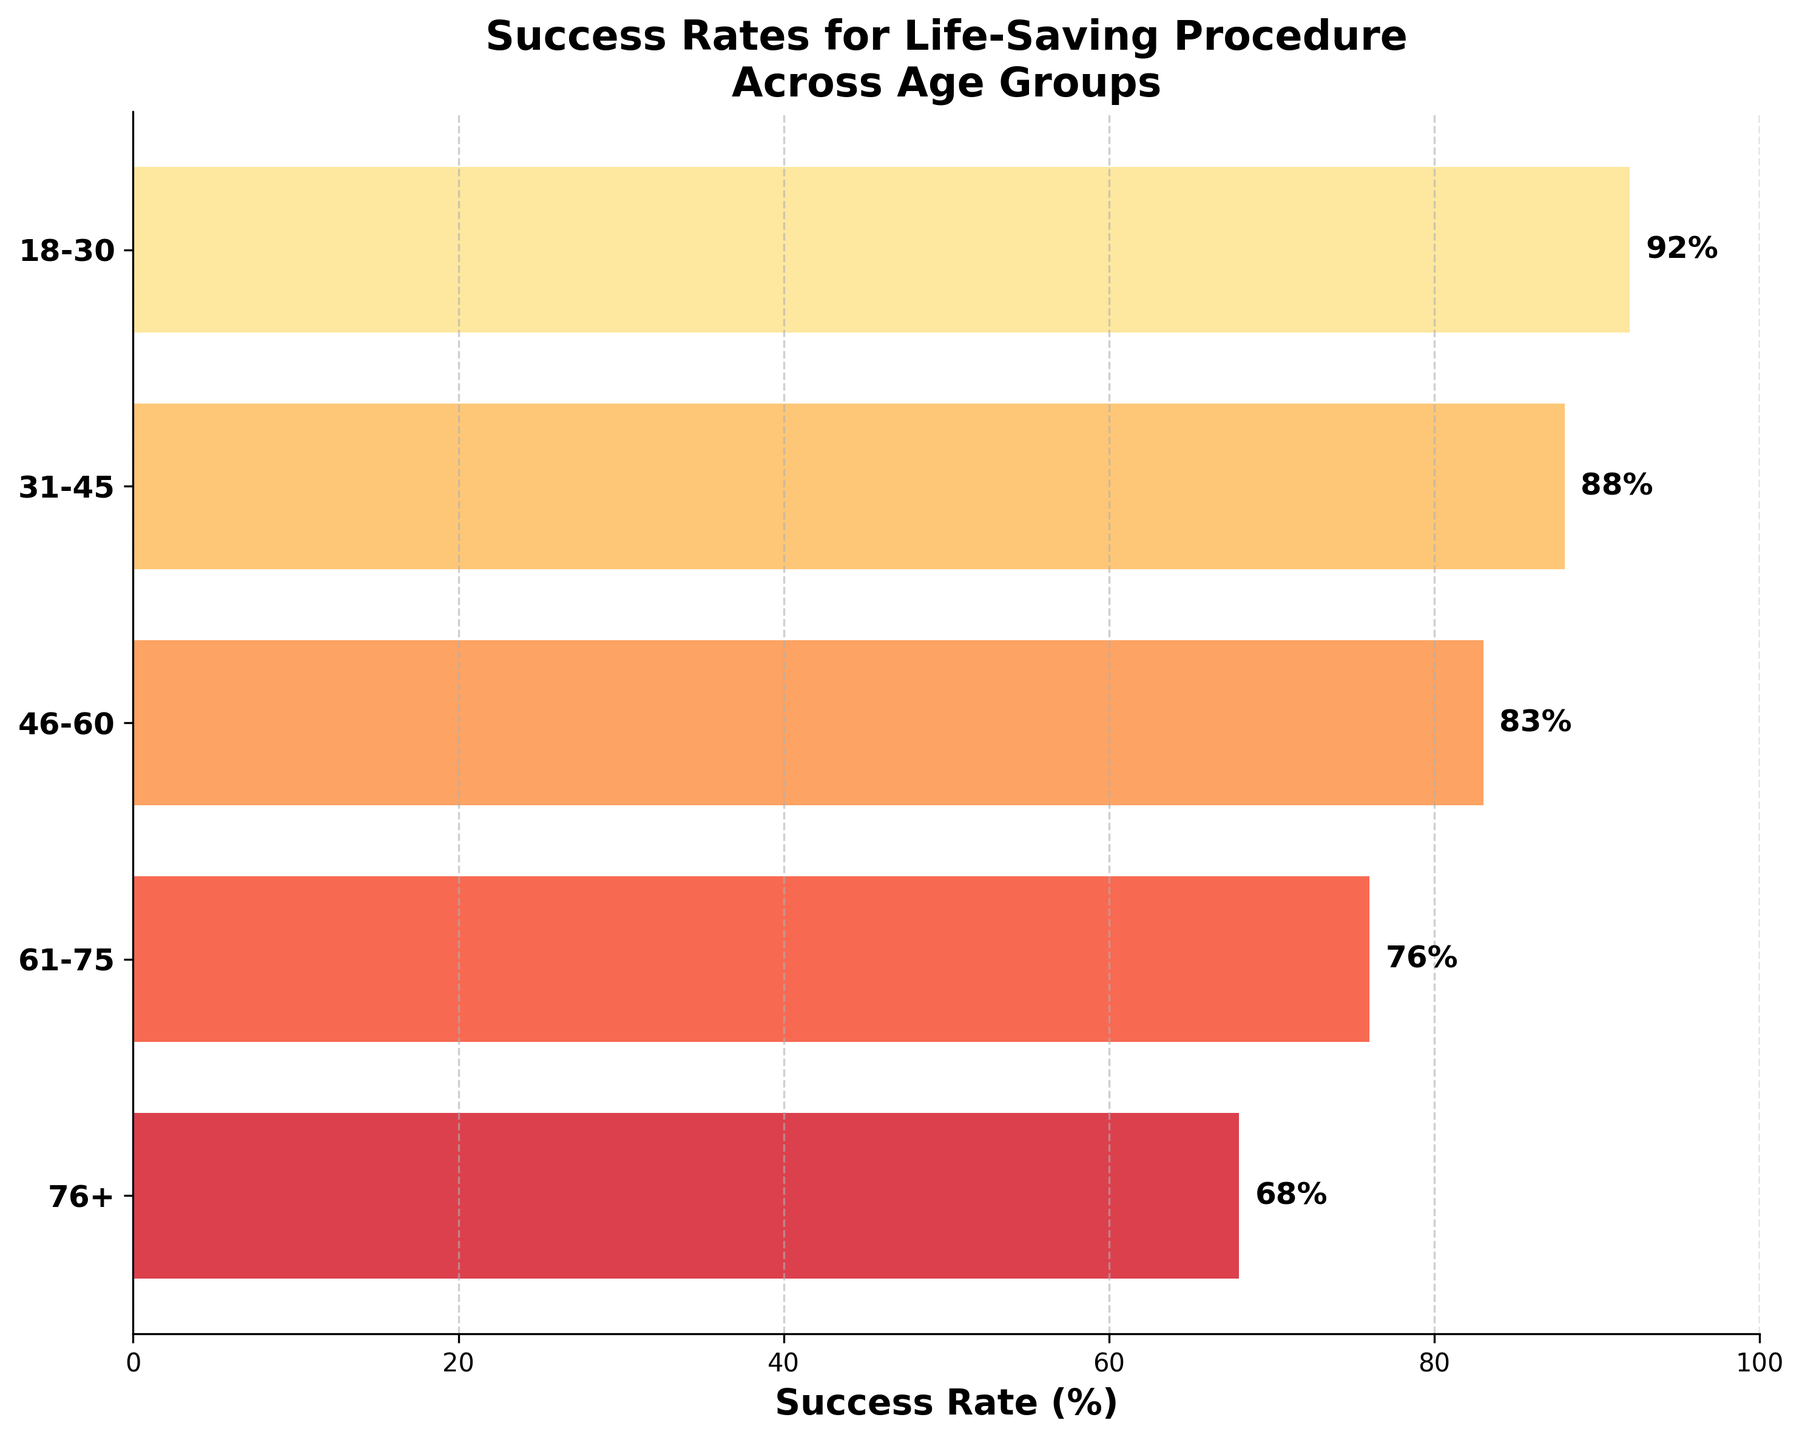What is the title of the plot? The title is typically displayed at the top of the plot. It summarizes the main idea or theme of the figure, which in this case is about the success rates of the procedure across different age groups.
Answer: Success Rates for Life-Saving Procedure Across Age Groups Which age group has the highest success rate? By examining the horizontal bars from top to bottom, the age group with the highest value on the x-axis will indicate the highest success rate in percentage.
Answer: 18-30 Which age group has the lowest success rate? By looking at the horizontal bars vertically, the lowest value on the x-axis indicates the age group with the lowest success rate in percentage.
Answer: 76+ What is the success rate for the 46-60 age group? Find and read the value at the end of the corresponding horizontal bar for the 46-60 age group.
Answer: 83% How much lower is the success rate for the 76+ age group compared to the 18-30 age group? Subtract the success rate of the 76+ group from that of the 18-30 group. (92% - 68%)
Answer: 24% What is the average success rate across all age groups? Sum all the success rates and divide by the number of age groups: (92 + 88 + 83 + 76 + 68) / 5 = 407 / 5.
Answer: 81.4% Which age group sees a steepest drop in success rate compared to the previous group? Calculate the differences between consecutive age groups' success rates: 18-30 to 31-45 (-4%), 31-45 to 46-60 (-5%), 46-60 to 61-75 (-7%), 61-75 to 76+ (-8%). The largest negative difference indicates the steepest drop.
Answer: 61-75 to 76+ How many age groups have a success rate above 80%? Count the number of age groups where the success rate is greater than 80%.
Answer: 3 What is the median success rate? Arrange the success rates in ascending order and find the middle value: 68, 76, 83, 88, 92. The middle value is the median.
Answer: 83% How are the colors used in the funnel chart correlated to the success rate values? Observe the gradient from lighter to darker shades. Higher success rates have lighter shades, and lower success rates have darker shades in the yellow-orange-red spectrum.
Answer: Higher success rates are lighter; lower success rates are darker 